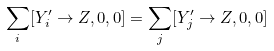Convert formula to latex. <formula><loc_0><loc_0><loc_500><loc_500>\sum _ { i } [ Y ^ { \prime } _ { i } \rightarrow Z , 0 , 0 ] = \sum _ { j } [ Y ^ { \prime } _ { j } \rightarrow Z , 0 , 0 ]</formula> 